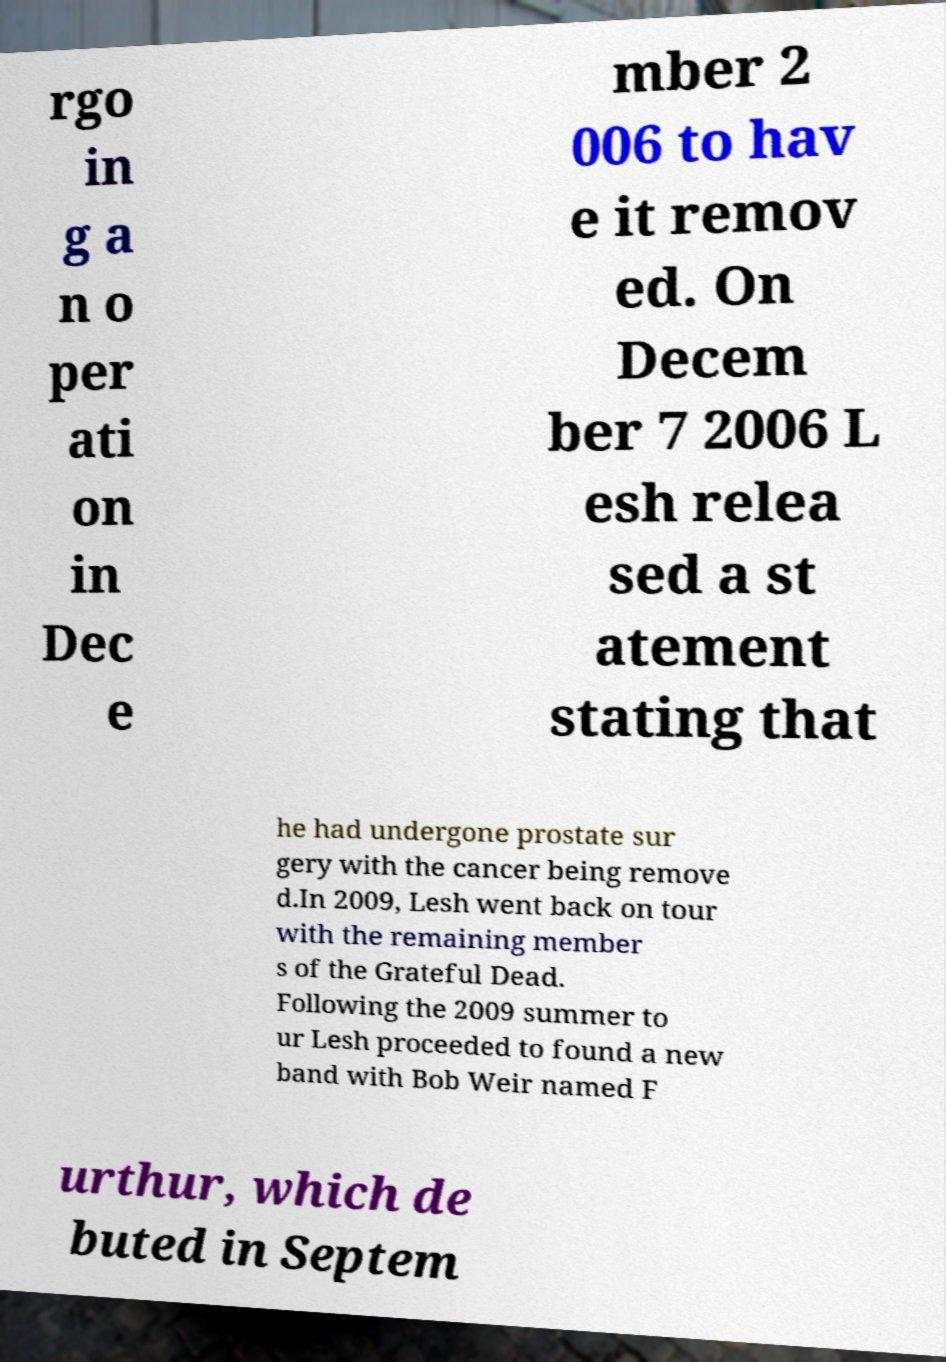For documentation purposes, I need the text within this image transcribed. Could you provide that? rgo in g a n o per ati on in Dec e mber 2 006 to hav e it remov ed. On Decem ber 7 2006 L esh relea sed a st atement stating that he had undergone prostate sur gery with the cancer being remove d.In 2009, Lesh went back on tour with the remaining member s of the Grateful Dead. Following the 2009 summer to ur Lesh proceeded to found a new band with Bob Weir named F urthur, which de buted in Septem 